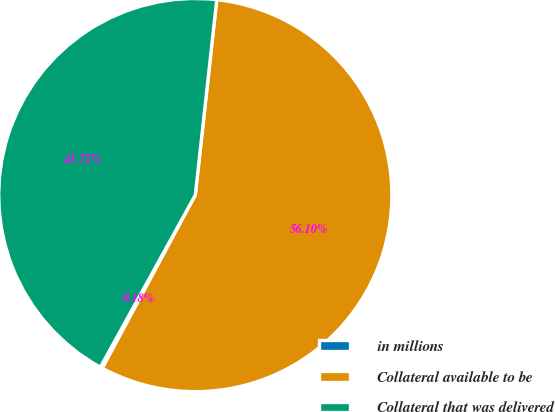Convert chart to OTSL. <chart><loc_0><loc_0><loc_500><loc_500><pie_chart><fcel>in millions<fcel>Collateral available to be<fcel>Collateral that was delivered<nl><fcel>0.18%<fcel>56.1%<fcel>43.72%<nl></chart> 